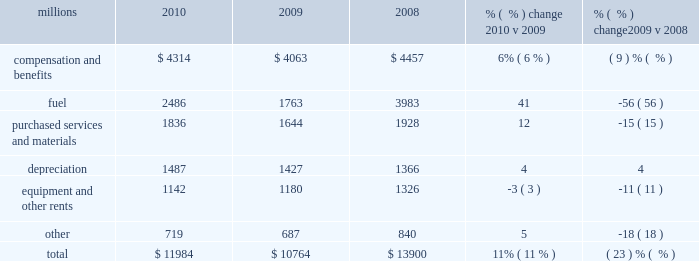Operating expenses millions 2010 2009 2008 % (  % ) change 2010 v 2009 % (  % ) change 2009 v 2008 .
Operating expenses increased $ 1.2 billion in 2010 versus 2009 .
Our fuel price per gallon increased 31% ( 31 % ) during the year , accounting for $ 566 million of the increase .
Wage and benefit inflation , depreciation , volume-related costs , and property taxes also contributed to higher expenses during 2010 compared to 2009 .
Cost savings from productivity improvements and better resource utilization partially offset these increases .
Operating expenses decreased $ 3.1 billion in 2009 versus 2008 .
Our fuel price per gallon declined 44% ( 44 % ) during 2009 , decreasing operating expenses by $ 1.3 billion compared to 2008 .
Cost savings from lower volume , productivity improvements , and better resource utilization also decreased operating expenses in 2009 .
In addition , lower casualty expense resulting primarily from improving trends in safety performance decreased operating expenses in 2009 .
Conversely , wage and benefit inflation partially offset these reductions .
Compensation and benefits 2013 compensation and benefits include wages , payroll taxes , health and welfare costs , pension costs , other postretirement benefits , and incentive costs .
General wage and benefit inflation increased costs by approximately $ 190 million in 2010 compared to 2009 .
Volume- related expenses and higher equity and incentive compensation also drove costs up during the year .
Workforce levels declined 1% ( 1 % ) in 2010 compared to 2009 as network efficiencies and ongoing productivity initiatives enabled us to effectively handle the 13% ( 13 % ) increase in volume levels with fewer employees .
Lower volume and productivity initiatives led to a 10% ( 10 % ) decline in our workforce in 2009 compared to 2008 , saving $ 516 million during the year .
Conversely , general wage and benefit inflation increased expenses , partially offsetting these savings .
Fuel 2013 fuel includes locomotive fuel and gasoline for highway and non-highway vehicles and heavy equipment .
Higher diesel fuel prices , which averaged $ 2.29 per gallon ( including taxes and transportation costs ) in 2010 compared to $ 1.75 per gallon in 2009 , increased expenses by $ 566 million .
Volume , as measured by gross ton-miles , increased 10% ( 10 % ) in 2010 versus 2009 , driving fuel expense up by $ 166 million .
Conversely , the use of newer , more fuel efficient locomotives , our fuel conservation programs and efficient network operations drove a 3% ( 3 % ) improvement in our fuel consumption rate in 2010 , resulting in $ 40 million of cost savings versus 2009 at the 2009 average fuel price .
Lower diesel fuel prices , which averaged $ 1.75 per gallon ( including taxes and transportation costs ) in 2009 compared to $ 3.15 per gallon in 2008 , reduced expenses by $ 1.3 billion in 2009 .
Volume , as measured by gross ton-miles , decreased 17% ( 17 % ) in 2009 , lowering expenses by $ 664 million compared to 2008 .
Our fuel consumption rate improved 4% ( 4 % ) in 2009 , resulting in $ 147 million of cost savings versus 2008 at the 2008 average fuel price .
The consumption rate savings versus 2008 using the lower 2009 fuel price was $ 68 million .
Newer , more fuel efficient locomotives , reflecting locomotive acquisitions in recent years and the impact of a smaller fleet due to storage of some of our older locomotives ; increased use of 2010 operating expenses .
In 2008 what was the percent of the total operating expenses that was for the compensation and benefits? 
Computations: (4457 / 13900)
Answer: 0.32065. 